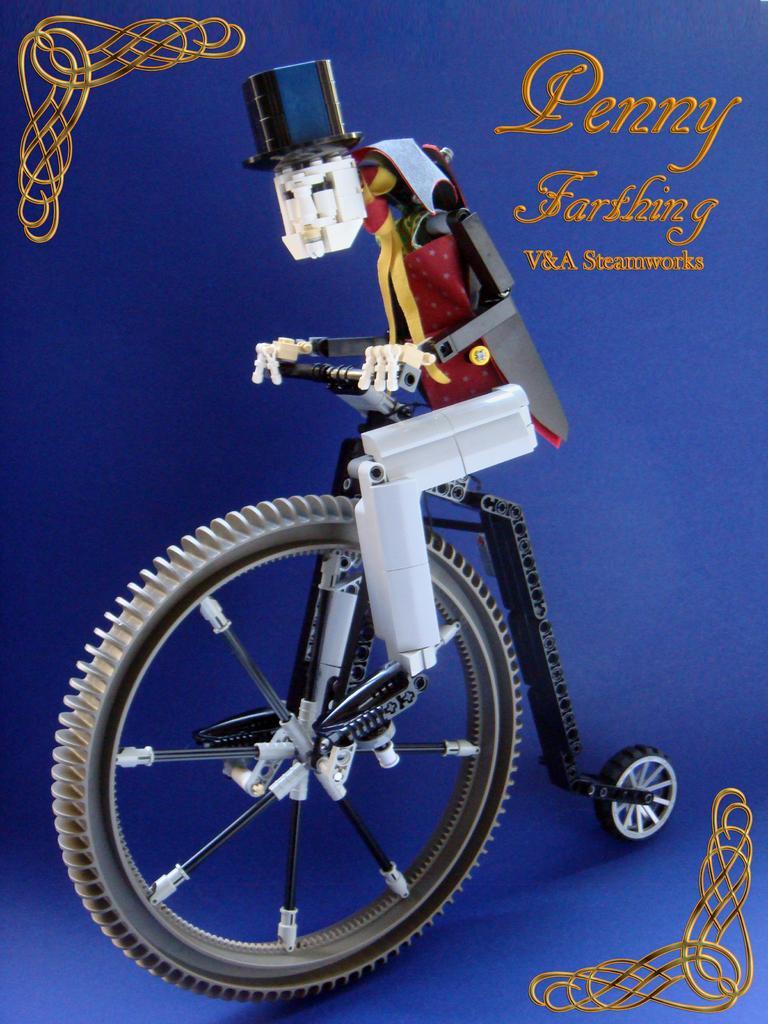Could you give a brief overview of what you see in this image? In this image, we can see a blue color poster. In this poster, we can see some design, text and toy. 